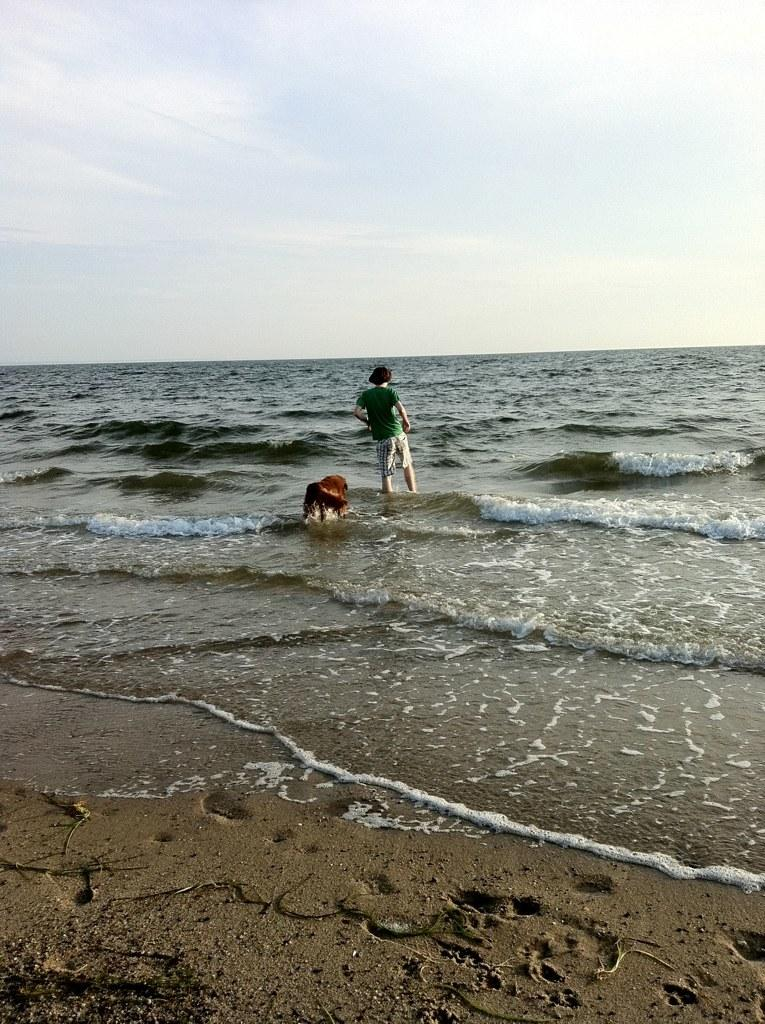What is the person in the image doing? The person is standing in the water. What can be seen in the background of the image? The sky is visible in the background of the image, and there is an unspecified "other thing" present as well. How many legs can be seen on the hand in the image? There is no hand or legs present in the image. What type of house is visible in the background of the image? There is no house visible in the background of the image. 